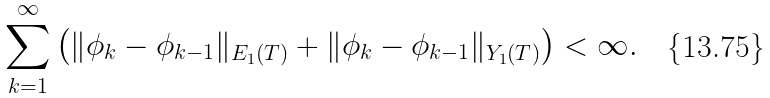<formula> <loc_0><loc_0><loc_500><loc_500>\sum _ { k = 1 } ^ { \infty } \left ( \| \phi _ { k } - \phi _ { k - 1 } \| _ { E _ { 1 } ( T ) } + \| \phi _ { k } - \phi _ { k - 1 } \| _ { Y _ { 1 } ( T ) } \right ) < \infty .</formula> 